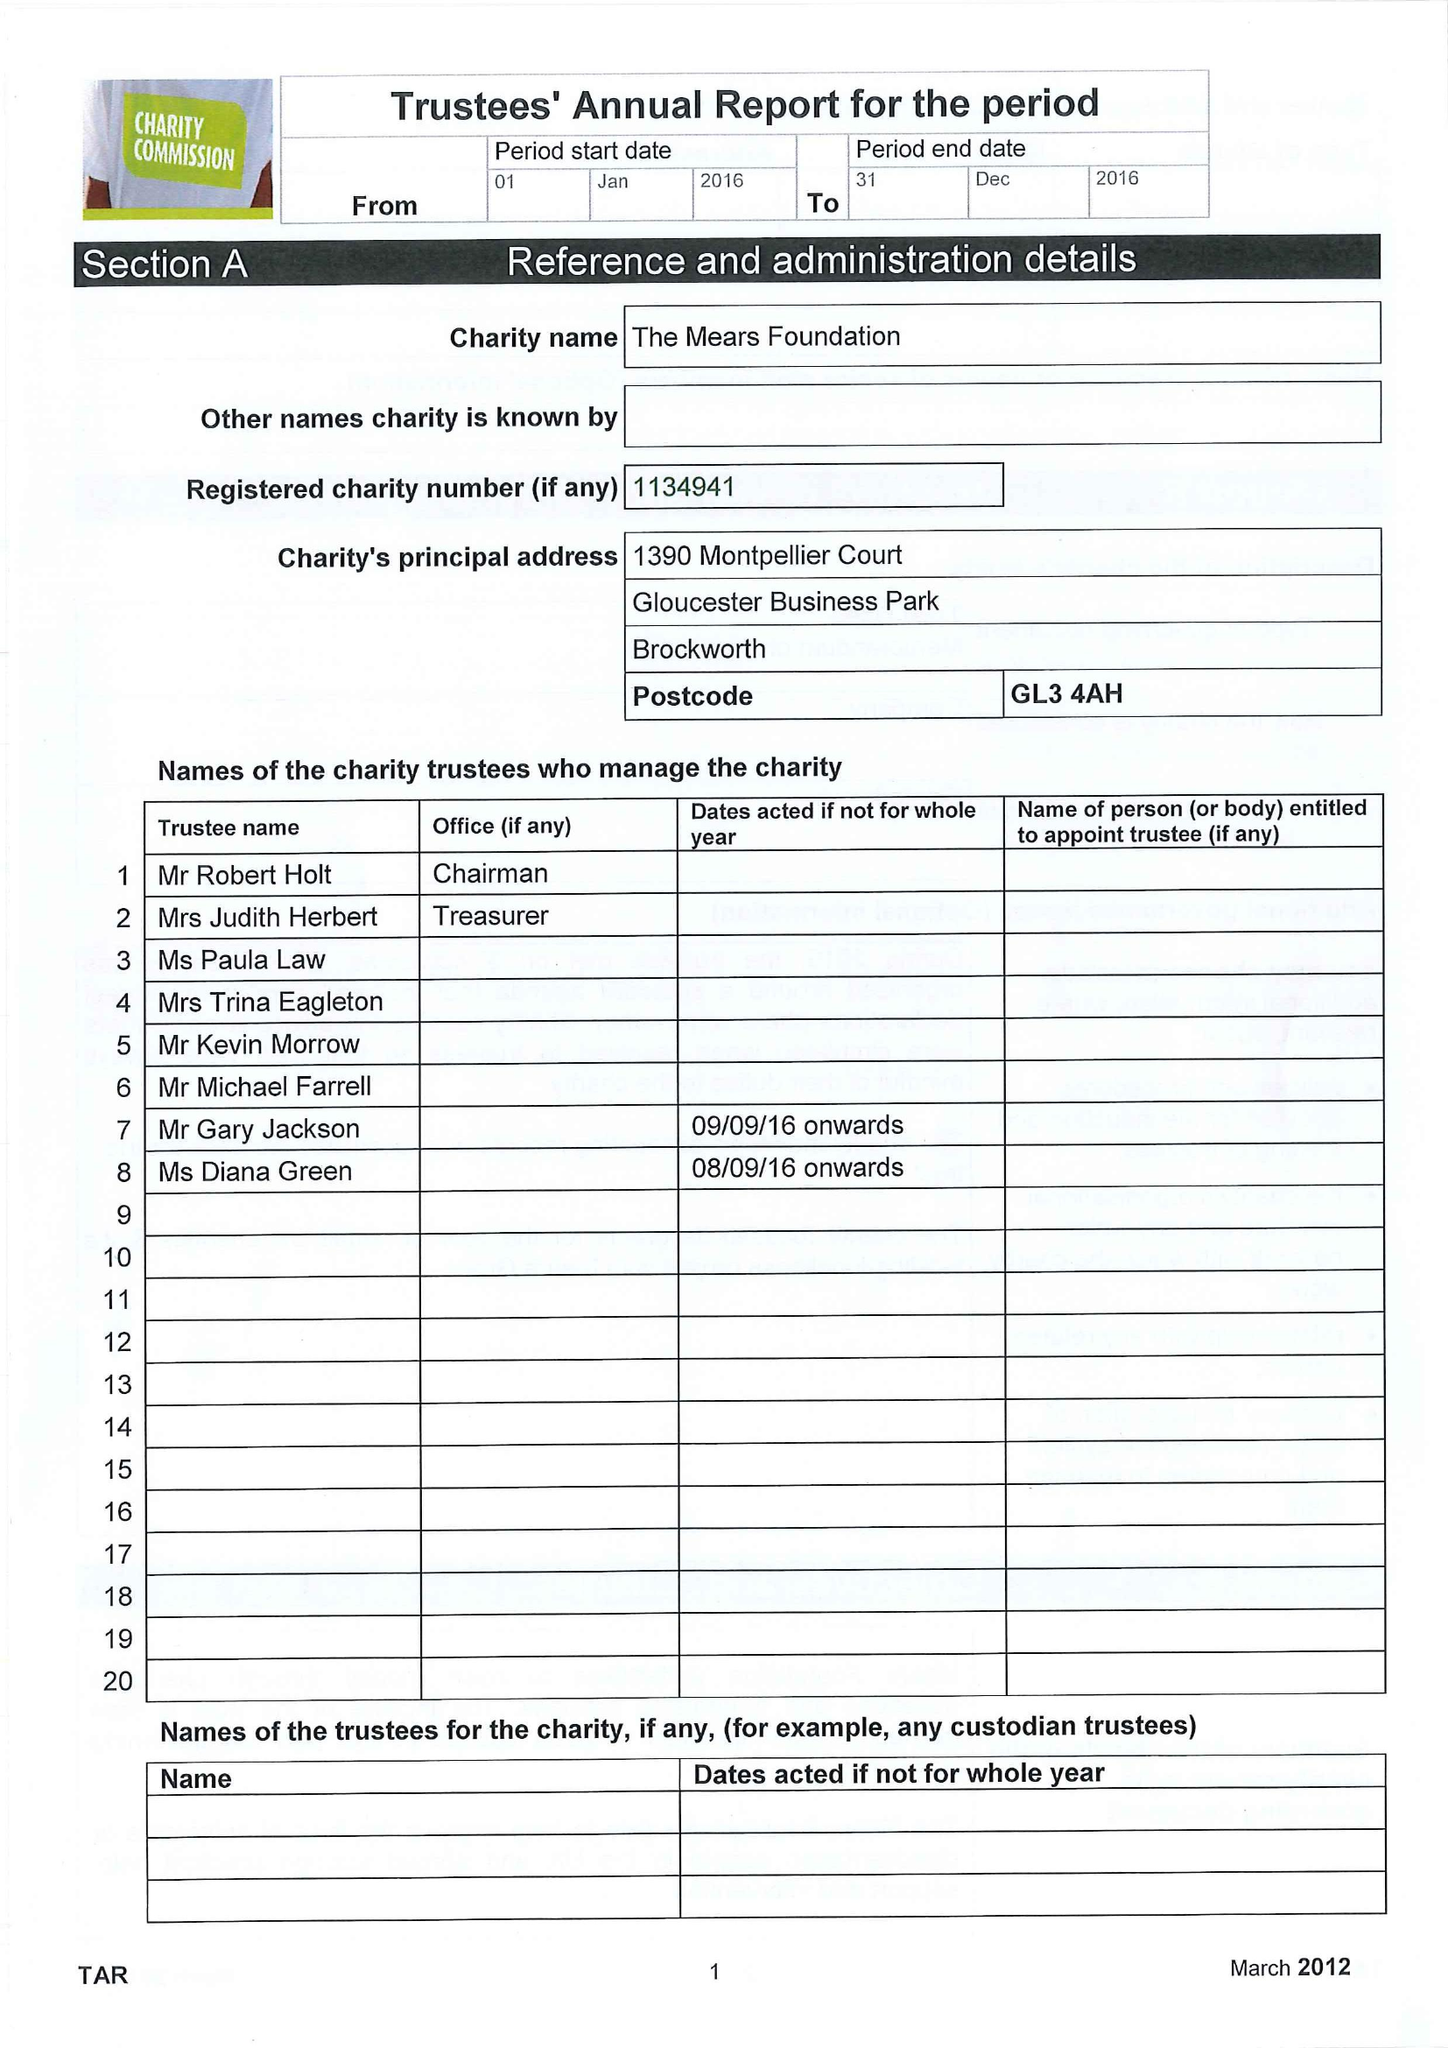What is the value for the charity_name?
Answer the question using a single word or phrase. The Mears Foundation 